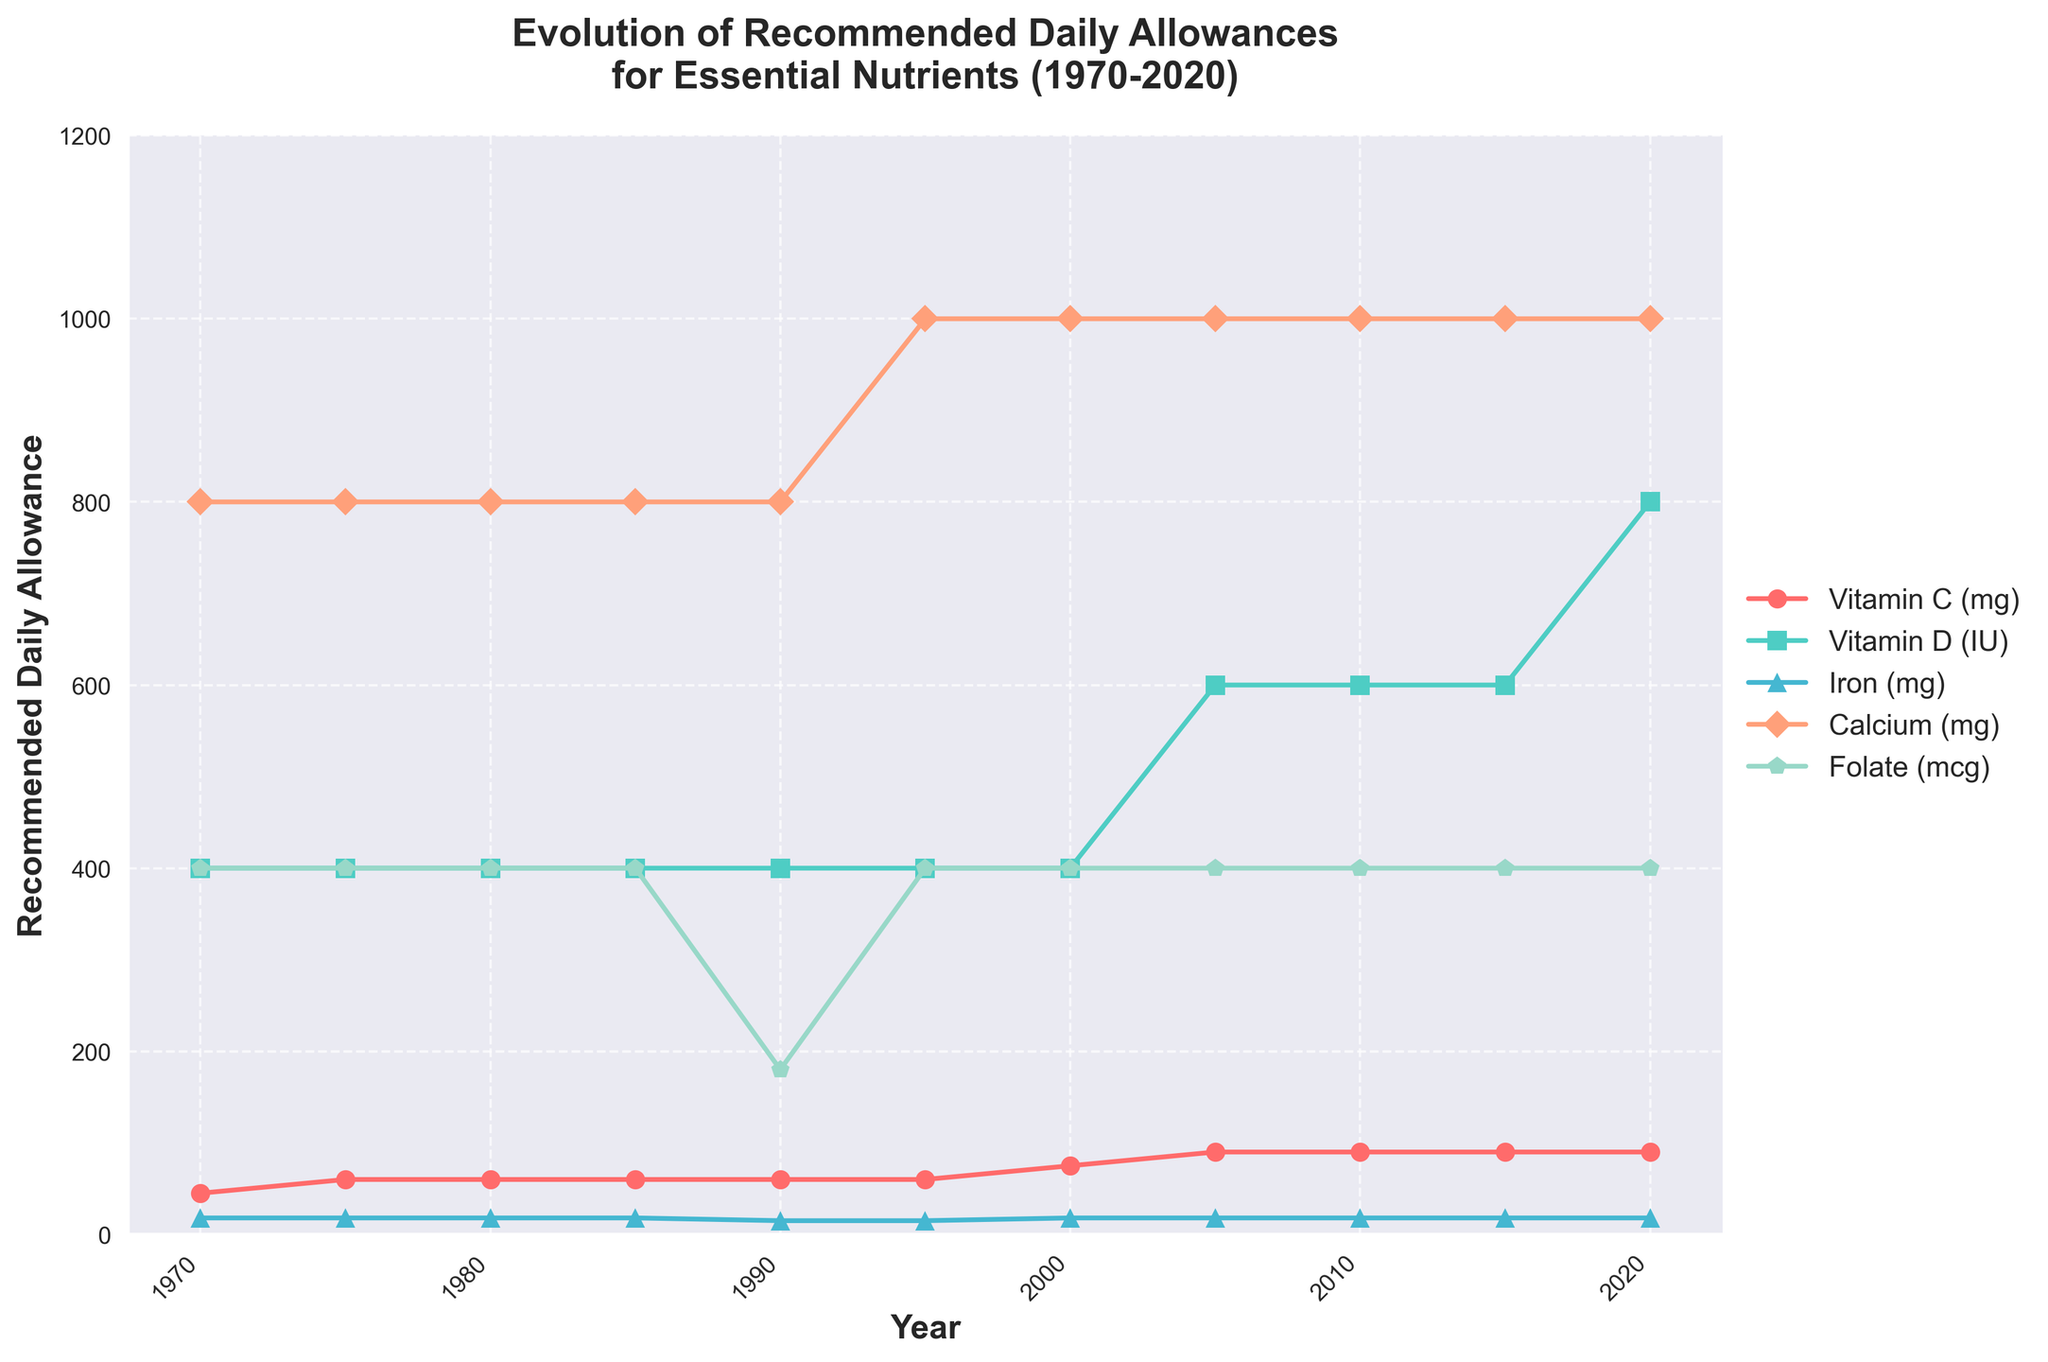What's the recommended daily allowance of Vitamin C in 1990? According to the plot, locate the year 1990 on the x-axis and follow the line representing Vitamin C (in red) vertically to find its value on the y-axis. The value is 60 mg.
Answer: 60 mg What year did the recommended daily allowance for Folate drop significantly, and by how much? Follow the Folate line (in green) and identify the largest drop. This occurs between 1985 and 1990 where it drops from 400 mcg to 180 mcg. The decrease is 220 mcg.
Answer: 1990, 220 mcg Which nutrient had an increase in the recommended daily allowance in 2020 compared to 1970, and by how much? Check the values for each nutrient in 1970 and 2020. Vitamin C goes from 45 mg to 90 mg (increase of 45), Vitamin D goes from 400 IU to 800 IU (increase of 400), and Calcium remains the same. Therefore, Vitamin C and Vitamin D both increased.
Answer: Vitamin C: 45 mg, Vitamin D: 400 IU What is the difference in the recommended daily allowance for Calcium between 1970 and 2020? Locate the values for Calcium in 1970 and 2020 on the plot. Both values are 800 mg, so the difference is 0.
Answer: 0 In which year did Vitamin D see its first increase, and what was the new value? Follow the Vitamin D line (in turquoise) and identify the year of the first change. This increase occurs in 2005 when the value changes from 400 IU to 600 IU.
Answer: 2005, 600 IU What is the trend in the recommended daily allowance for Iron from 1970 to 2020? Follow the Iron line (in blue) from 1970 to 2020. It remains constant at 18 mg except for a decrease to 15 mg in 1990 and returning to 18 mg in 2000. Overall, there's no significant trend change.
Answer: Mostly constant Between which consecutive years did Vitamin C see its largest increase, and by how much? Follow the Vitamin C line (in red) and find the segment with the largest increase. This occurs between 1995 and 2000, where the value increased from 60 mg to 75 mg, a rise of 15 mg.
Answer: 1995 to 2000, 15 mg 